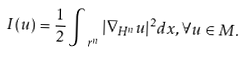<formula> <loc_0><loc_0><loc_500><loc_500>I ( u ) = \frac { 1 } { 2 } \int _ { \ r ^ { n } } | \nabla _ { H ^ { n } } u | ^ { 2 } d x , \forall u \in M .</formula> 